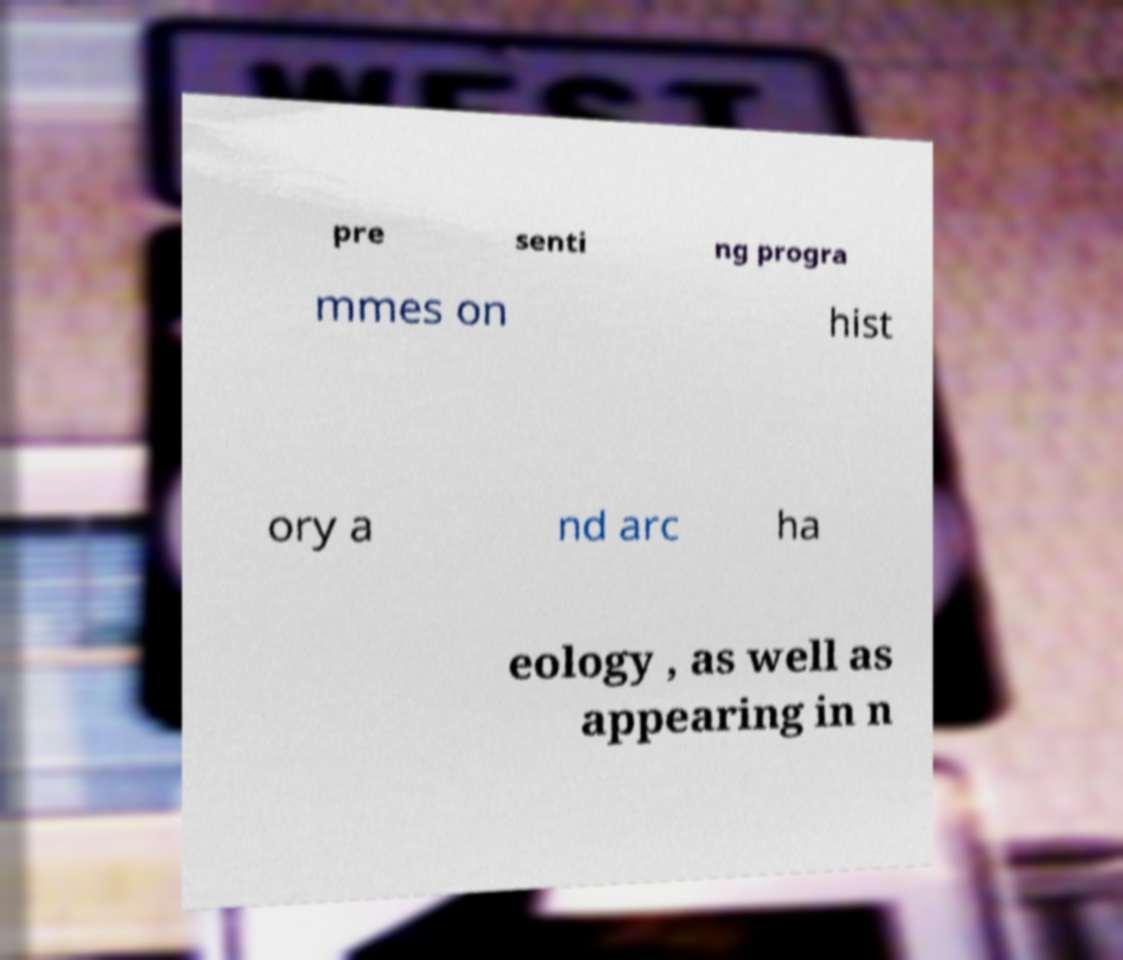There's text embedded in this image that I need extracted. Can you transcribe it verbatim? pre senti ng progra mmes on hist ory a nd arc ha eology , as well as appearing in n 